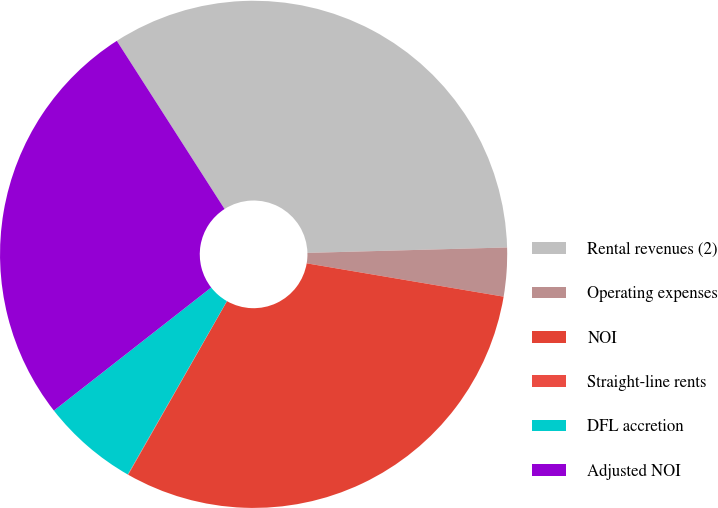Convert chart. <chart><loc_0><loc_0><loc_500><loc_500><pie_chart><fcel>Rental revenues (2)<fcel>Operating expenses<fcel>NOI<fcel>Straight-line rents<fcel>DFL accretion<fcel>Adjusted NOI<nl><fcel>33.64%<fcel>3.1%<fcel>30.57%<fcel>0.03%<fcel>6.17%<fcel>26.5%<nl></chart> 